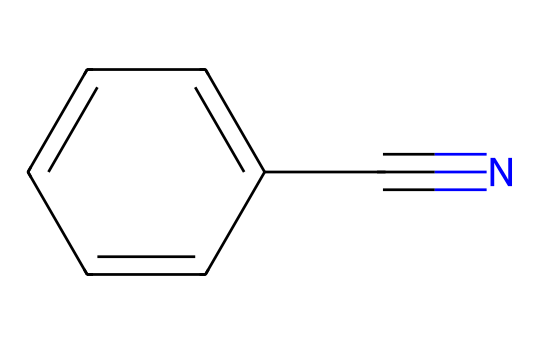What is the molecular formula of benzonitrile? The SMILES representation indicates that the structure consists of a benzene ring (6 carbon atoms) and a cyano group (1 carbon and 1 nitrogen atom), resulting in the formula C7H5N.
Answer: C7H5N How many carbon atoms are in benzonitrile? By analyzing the SMILES notation, there are six carbon atoms in the benzene part of the molecule and one carbon atom in the cyano group, making a total of seven carbon atoms.
Answer: 7 What functional group is present in benzonitrile? The cyano group represented by "C#N" in the SMILES indicates the presence of a nitrile functional group. This is characteristic of nitriles and essential for their properties.
Answer: nitrile How does the presence of the nitrogen atom affect the chemical properties of benzonitrile? The nitrogen atom in the cyano group (C#N) increases the polarity of the molecule, which can enhance its solubility in polar solvents and influence its chemical reactivity.
Answer: increases polarity Why is benzonitrile considered safe for pet-friendly pesticides? Benzonitrile's structure and properties make it less toxic to mammals and non-target organisms compared to other pesticides, which is vital for creating environmentally-friendly products.
Answer: less toxic What type of compound is benzonitrile in terms of its bonding? The connectivity in benzonitrile includes both aromatic carbon-to-carbon bonds in the benzene ring and a triple bond between carbon and nitrogen in the cyano group, categorizing it as an aromatic nitrile.
Answer: aromatic nitrile 